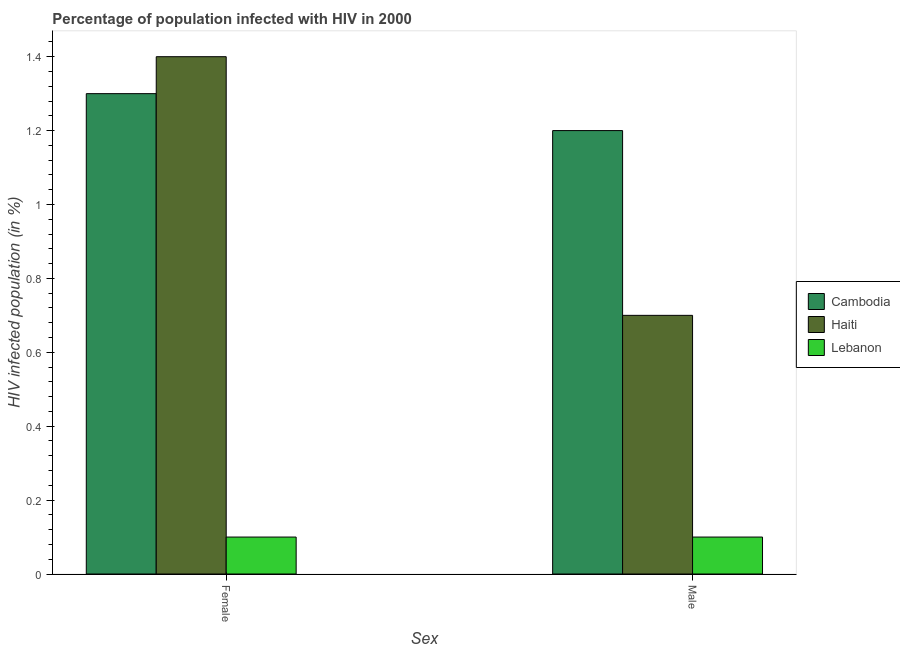Are the number of bars on each tick of the X-axis equal?
Your answer should be compact. Yes. How many bars are there on the 2nd tick from the right?
Your response must be concise. 3. Across all countries, what is the minimum percentage of males who are infected with hiv?
Offer a very short reply. 0.1. In which country was the percentage of females who are infected with hiv maximum?
Ensure brevity in your answer.  Haiti. In which country was the percentage of males who are infected with hiv minimum?
Ensure brevity in your answer.  Lebanon. What is the total percentage of females who are infected with hiv in the graph?
Provide a short and direct response. 2.8. What is the difference between the percentage of females who are infected with hiv in Cambodia and the percentage of males who are infected with hiv in Haiti?
Offer a very short reply. 0.6. What is the average percentage of males who are infected with hiv per country?
Keep it short and to the point. 0.67. What is the difference between the percentage of females who are infected with hiv and percentage of males who are infected with hiv in Cambodia?
Offer a terse response. 0.1. In how many countries, is the percentage of males who are infected with hiv greater than 1.12 %?
Give a very brief answer. 1. What is the ratio of the percentage of males who are infected with hiv in Cambodia to that in Haiti?
Keep it short and to the point. 1.71. What does the 2nd bar from the left in Male represents?
Provide a short and direct response. Haiti. What does the 1st bar from the right in Male represents?
Offer a very short reply. Lebanon. How many bars are there?
Provide a succinct answer. 6. Are all the bars in the graph horizontal?
Ensure brevity in your answer.  No. How many countries are there in the graph?
Provide a short and direct response. 3. Are the values on the major ticks of Y-axis written in scientific E-notation?
Give a very brief answer. No. Does the graph contain any zero values?
Provide a succinct answer. No. Does the graph contain grids?
Give a very brief answer. No. Where does the legend appear in the graph?
Your answer should be compact. Center right. How many legend labels are there?
Your answer should be compact. 3. How are the legend labels stacked?
Give a very brief answer. Vertical. What is the title of the graph?
Keep it short and to the point. Percentage of population infected with HIV in 2000. What is the label or title of the X-axis?
Your answer should be very brief. Sex. What is the label or title of the Y-axis?
Keep it short and to the point. HIV infected population (in %). What is the HIV infected population (in %) in Haiti in Male?
Keep it short and to the point. 0.7. Across all Sex, what is the maximum HIV infected population (in %) in Cambodia?
Ensure brevity in your answer.  1.3. Across all Sex, what is the maximum HIV infected population (in %) of Lebanon?
Your answer should be very brief. 0.1. Across all Sex, what is the minimum HIV infected population (in %) of Cambodia?
Your answer should be very brief. 1.2. What is the total HIV infected population (in %) in Cambodia in the graph?
Provide a succinct answer. 2.5. What is the total HIV infected population (in %) in Lebanon in the graph?
Offer a very short reply. 0.2. What is the difference between the HIV infected population (in %) in Cambodia in Female and that in Male?
Ensure brevity in your answer.  0.1. What is the difference between the HIV infected population (in %) of Lebanon in Female and that in Male?
Make the answer very short. 0. What is the difference between the HIV infected population (in %) of Cambodia in Female and the HIV infected population (in %) of Haiti in Male?
Make the answer very short. 0.6. What is the difference between the HIV infected population (in %) in Haiti in Female and the HIV infected population (in %) in Lebanon in Male?
Your answer should be very brief. 1.3. What is the average HIV infected population (in %) in Haiti per Sex?
Ensure brevity in your answer.  1.05. What is the difference between the HIV infected population (in %) in Cambodia and HIV infected population (in %) in Haiti in Female?
Provide a short and direct response. -0.1. What is the difference between the HIV infected population (in %) of Cambodia and HIV infected population (in %) of Lebanon in Female?
Your response must be concise. 1.2. What is the difference between the HIV infected population (in %) in Haiti and HIV infected population (in %) in Lebanon in Female?
Keep it short and to the point. 1.3. What is the difference between the HIV infected population (in %) in Cambodia and HIV infected population (in %) in Haiti in Male?
Make the answer very short. 0.5. What is the difference between the HIV infected population (in %) in Cambodia and HIV infected population (in %) in Lebanon in Male?
Offer a terse response. 1.1. What is the ratio of the HIV infected population (in %) of Cambodia in Female to that in Male?
Your answer should be very brief. 1.08. What is the ratio of the HIV infected population (in %) in Haiti in Female to that in Male?
Your response must be concise. 2. What is the ratio of the HIV infected population (in %) of Lebanon in Female to that in Male?
Your answer should be compact. 1. What is the difference between the highest and the lowest HIV infected population (in %) of Haiti?
Offer a terse response. 0.7. 